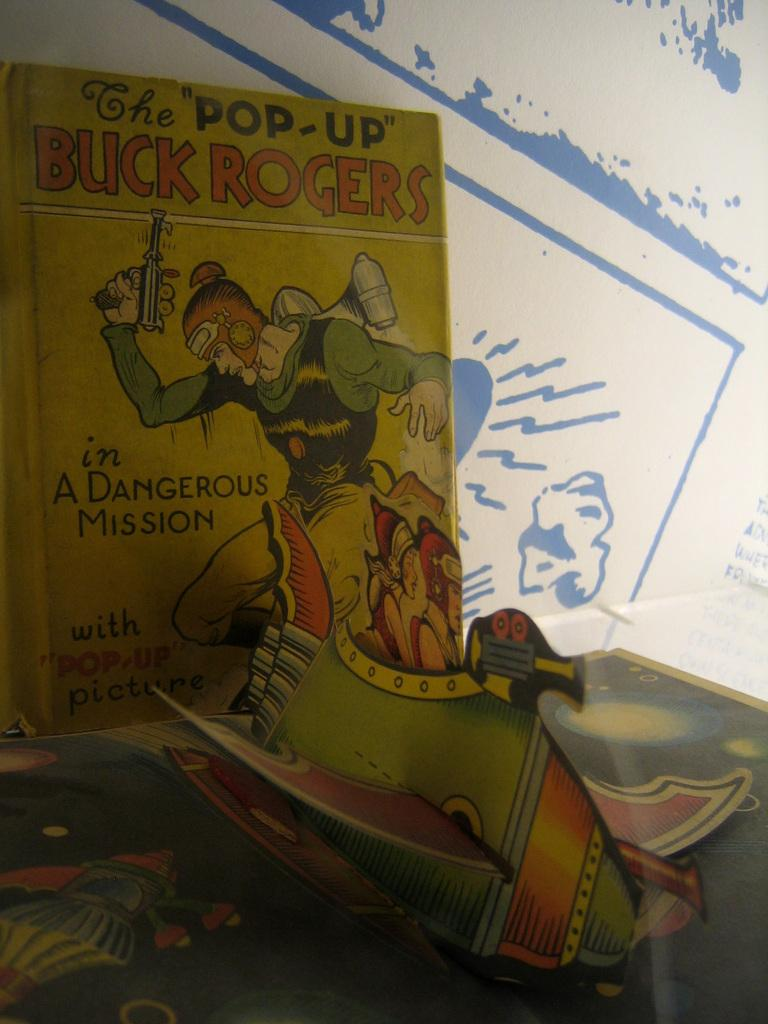<image>
Relay a brief, clear account of the picture shown. The Pop-Up Buck Rogers book shows a man wearing a helmet on the cover. 